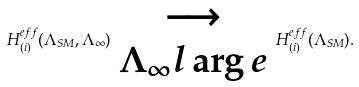Convert formula to latex. <formula><loc_0><loc_0><loc_500><loc_500>H ^ { e f f } _ { ( i ) } ( \Lambda _ { S M } , \Lambda _ { \infty } ) \begin{array} [ t ] { c } \longrightarrow \\ \Lambda _ { \infty } l \arg e \end{array} H ^ { e f f } _ { ( i ) } ( \Lambda _ { S M } ) .</formula> 